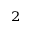Convert formula to latex. <formula><loc_0><loc_0><loc_500><loc_500>^ { 2 }</formula> 